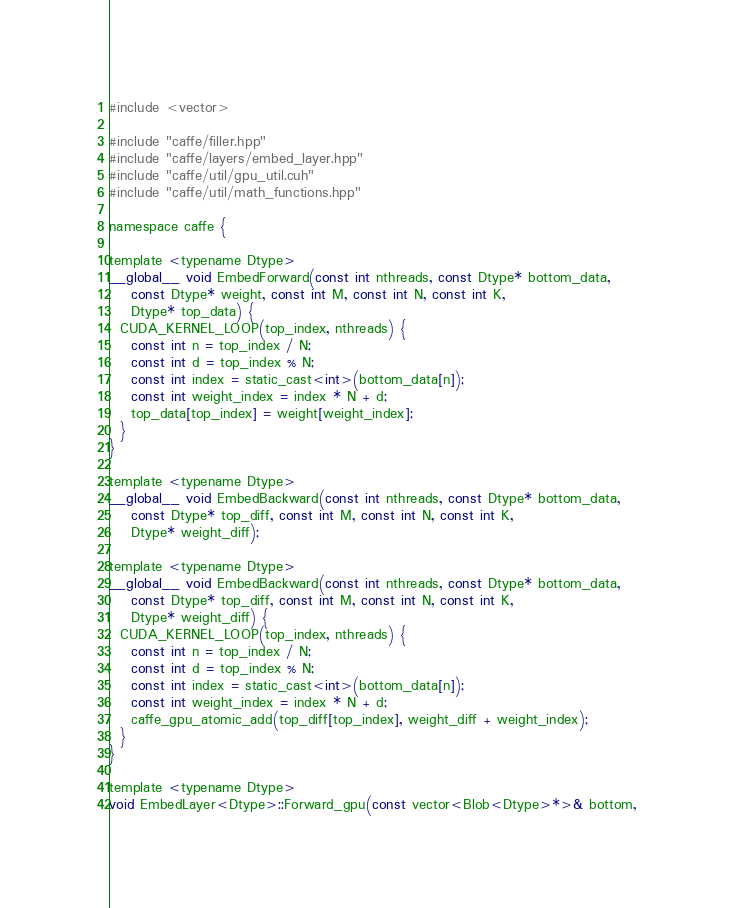Convert code to text. <code><loc_0><loc_0><loc_500><loc_500><_Cuda_>#include <vector>

#include "caffe/filler.hpp"
#include "caffe/layers/embed_layer.hpp"
#include "caffe/util/gpu_util.cuh"
#include "caffe/util/math_functions.hpp"

namespace caffe {

template <typename Dtype>
__global__ void EmbedForward(const int nthreads, const Dtype* bottom_data,
    const Dtype* weight, const int M, const int N, const int K,
    Dtype* top_data) {
  CUDA_KERNEL_LOOP(top_index, nthreads) {
    const int n = top_index / N;
    const int d = top_index % N;
    const int index = static_cast<int>(bottom_data[n]);
    const int weight_index = index * N + d;
    top_data[top_index] = weight[weight_index];
  }
}

template <typename Dtype>
__global__ void EmbedBackward(const int nthreads, const Dtype* bottom_data,
    const Dtype* top_diff, const int M, const int N, const int K,
    Dtype* weight_diff);

template <typename Dtype>
__global__ void EmbedBackward(const int nthreads, const Dtype* bottom_data,
    const Dtype* top_diff, const int M, const int N, const int K,
    Dtype* weight_diff) {
  CUDA_KERNEL_LOOP(top_index, nthreads) {
    const int n = top_index / N;
    const int d = top_index % N;
    const int index = static_cast<int>(bottom_data[n]);
    const int weight_index = index * N + d;
    caffe_gpu_atomic_add(top_diff[top_index], weight_diff + weight_index);
  }
}

template <typename Dtype>
void EmbedLayer<Dtype>::Forward_gpu(const vector<Blob<Dtype>*>& bottom,</code> 